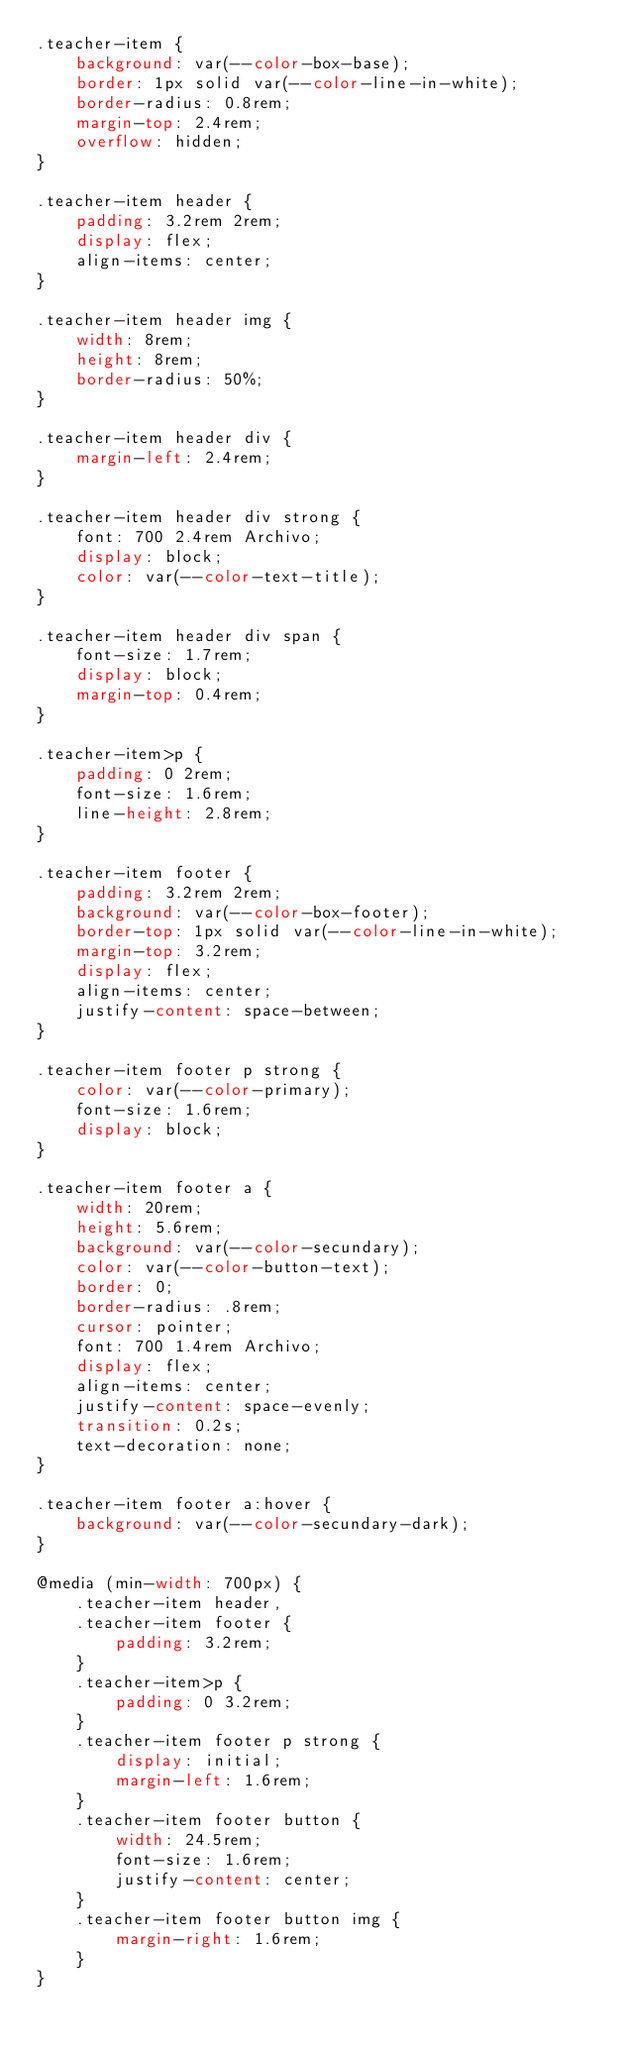Convert code to text. <code><loc_0><loc_0><loc_500><loc_500><_CSS_>.teacher-item {
    background: var(--color-box-base);
    border: 1px solid var(--color-line-in-white);
    border-radius: 0.8rem;
    margin-top: 2.4rem;
    overflow: hidden;
}

.teacher-item header {
    padding: 3.2rem 2rem;
    display: flex;
    align-items: center;
}

.teacher-item header img {
    width: 8rem;
    height: 8rem;
    border-radius: 50%;
}

.teacher-item header div {
    margin-left: 2.4rem;
}

.teacher-item header div strong {
    font: 700 2.4rem Archivo;
    display: block;
    color: var(--color-text-title);
}

.teacher-item header div span {
    font-size: 1.7rem;
    display: block;
    margin-top: 0.4rem;
}

.teacher-item>p {
    padding: 0 2rem;
    font-size: 1.6rem;
    line-height: 2.8rem;
}

.teacher-item footer {
    padding: 3.2rem 2rem;
    background: var(--color-box-footer);
    border-top: 1px solid var(--color-line-in-white);
    margin-top: 3.2rem;
    display: flex;
    align-items: center;
    justify-content: space-between;
}

.teacher-item footer p strong {
    color: var(--color-primary);
    font-size: 1.6rem;
    display: block;
}

.teacher-item footer a {
    width: 20rem;
    height: 5.6rem;
    background: var(--color-secundary);
    color: var(--color-button-text);
    border: 0;
    border-radius: .8rem;
    cursor: pointer;
    font: 700 1.4rem Archivo;
    display: flex;
    align-items: center;
    justify-content: space-evenly;
    transition: 0.2s;
    text-decoration: none;
}

.teacher-item footer a:hover {
    background: var(--color-secundary-dark);
}

@media (min-width: 700px) {
    .teacher-item header,
    .teacher-item footer {
        padding: 3.2rem;
    }
    .teacher-item>p {
        padding: 0 3.2rem;
    }
    .teacher-item footer p strong {
        display: initial;
        margin-left: 1.6rem;
    }
    .teacher-item footer button {
        width: 24.5rem;
        font-size: 1.6rem;
        justify-content: center;
    }
    .teacher-item footer button img {
        margin-right: 1.6rem;
    }
}</code> 